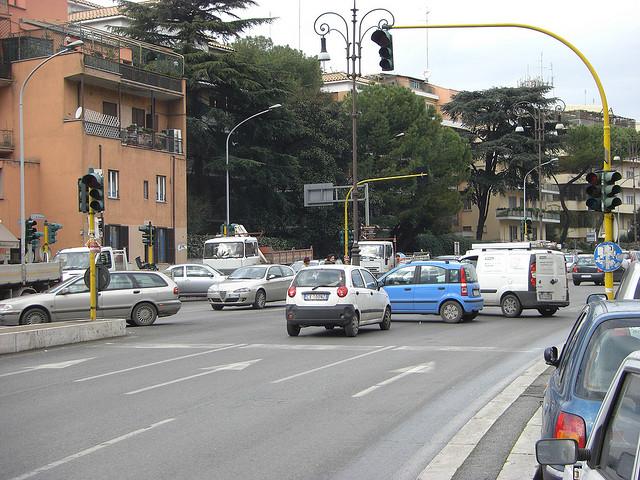What color are the poles of the street light?
Write a very short answer. Yellow. Will there be an accident?
Concise answer only. Yes. Are the streets busy?
Short answer required. Yes. What is the weather like?
Write a very short answer. Overcast. 